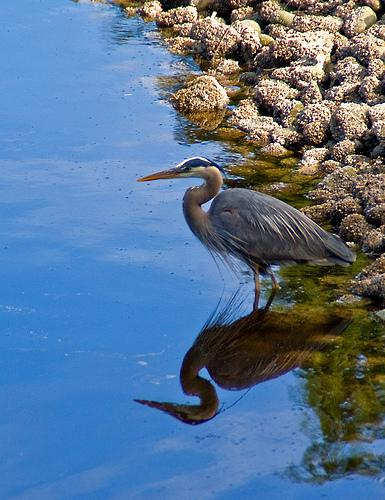Question: where was the photo taken?
Choices:
A. Close to the spring.
B. Close to the lake.
C. Close to the ocean.
D. Close to the river.
Answer with the letter. Answer: B Question: what is in the water?
Choices:
A. A bird.
B. Alligator.
C. A boat.
D. A frog.
Answer with the letter. Answer: A Question: where is the bird?
Choices:
A. In the sky.
B. In the water.
C. In a nest.
D. On the grass.
Answer with the letter. Answer: B 